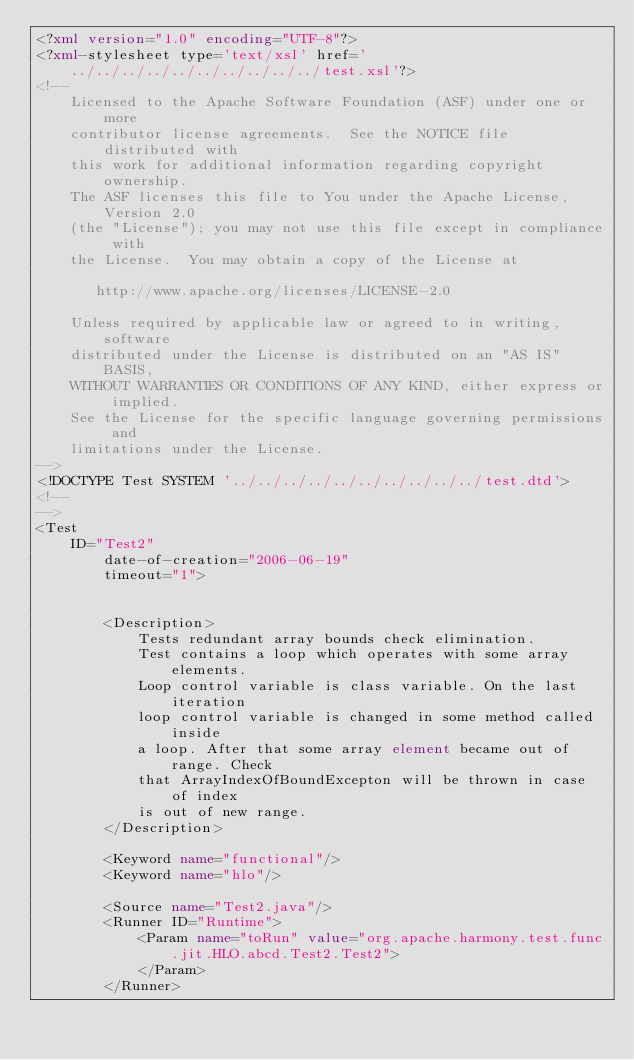Convert code to text. <code><loc_0><loc_0><loc_500><loc_500><_XML_><?xml version="1.0" encoding="UTF-8"?>
<?xml-stylesheet type='text/xsl' href='../../../../../../../../../../test.xsl'?>
<!--
    Licensed to the Apache Software Foundation (ASF) under one or more
    contributor license agreements.  See the NOTICE file distributed with
    this work for additional information regarding copyright ownership.
    The ASF licenses this file to You under the Apache License, Version 2.0
    (the "License"); you may not use this file except in compliance with
    the License.  You may obtain a copy of the License at
  
       http://www.apache.org/licenses/LICENSE-2.0
  
    Unless required by applicable law or agreed to in writing, software
    distributed under the License is distributed on an "AS IS" BASIS,
    WITHOUT WARRANTIES OR CONDITIONS OF ANY KIND, either express or implied.
    See the License for the specific language governing permissions and
    limitations under the License.
-->
<!DOCTYPE Test SYSTEM '../../../../../../../../../../test.dtd'>
<!--
-->
<Test
    ID="Test2"
        date-of-creation="2006-06-19"
        timeout="1">
        
        
        <Description>
            Tests redundant array bounds check elimination.
            Test contains a loop which operates with some array elements. 
            Loop control variable is class variable. On the last iteration 
            loop control variable is changed in some method called inside 
            a loop. After that some array element became out of range. Check 
            that ArrayIndexOfBoundExcepton will be thrown in case of index 
            is out of new range.
        </Description>
    
        <Keyword name="functional"/>
        <Keyword name="hlo"/>
        
        <Source name="Test2.java"/>
        <Runner ID="Runtime">
            <Param name="toRun" value="org.apache.harmony.test.func.jit.HLO.abcd.Test2.Test2">
            </Param>
        </Runner></code> 